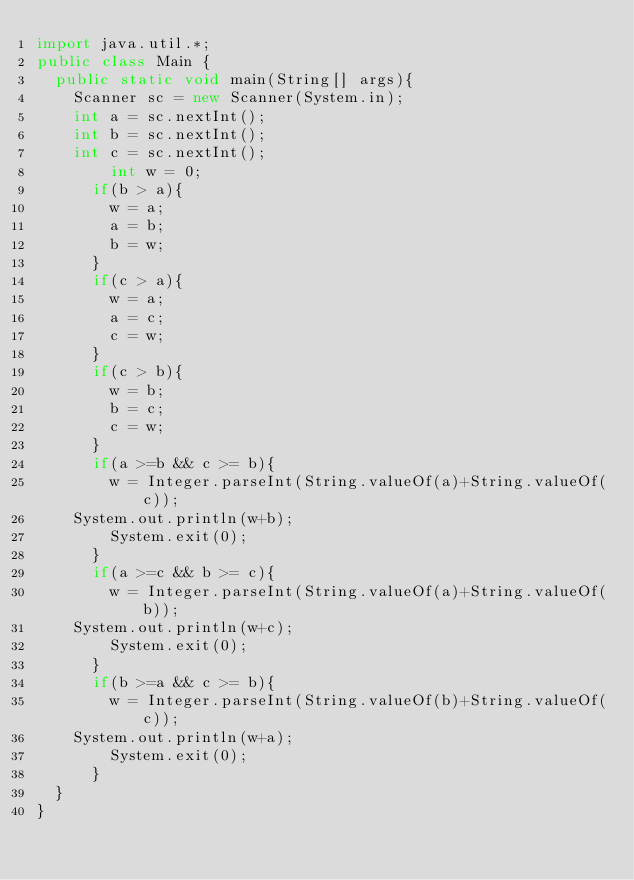<code> <loc_0><loc_0><loc_500><loc_500><_Java_>import java.util.*;
public class Main {
	public static void main(String[] args){
		Scanner sc = new Scanner(System.in);
		int a = sc.nextInt();
		int b = sc.nextInt();
		int c = sc.nextInt();
        int w = 0;
      if(b > a){
        w = a;
        a = b;
        b = w;
      }
      if(c > a){
        w = a;
        a = c;
        c = w;
      }
      if(c > b){
        w = b;
        b = c;
        c = w;
      }
      if(a >=b && c >= b){
        w = Integer.parseInt(String.valueOf(a)+String.valueOf(c));
		System.out.println(w+b);
        System.exit(0);
      }
      if(a >=c && b >= c){
        w = Integer.parseInt(String.valueOf(a)+String.valueOf(b));
		System.out.println(w+c);
        System.exit(0);
      }
      if(b >=a && c >= b){
        w = Integer.parseInt(String.valueOf(b)+String.valueOf(c));
		System.out.println(w+a);
        System.exit(0);
      }
	}
}</code> 